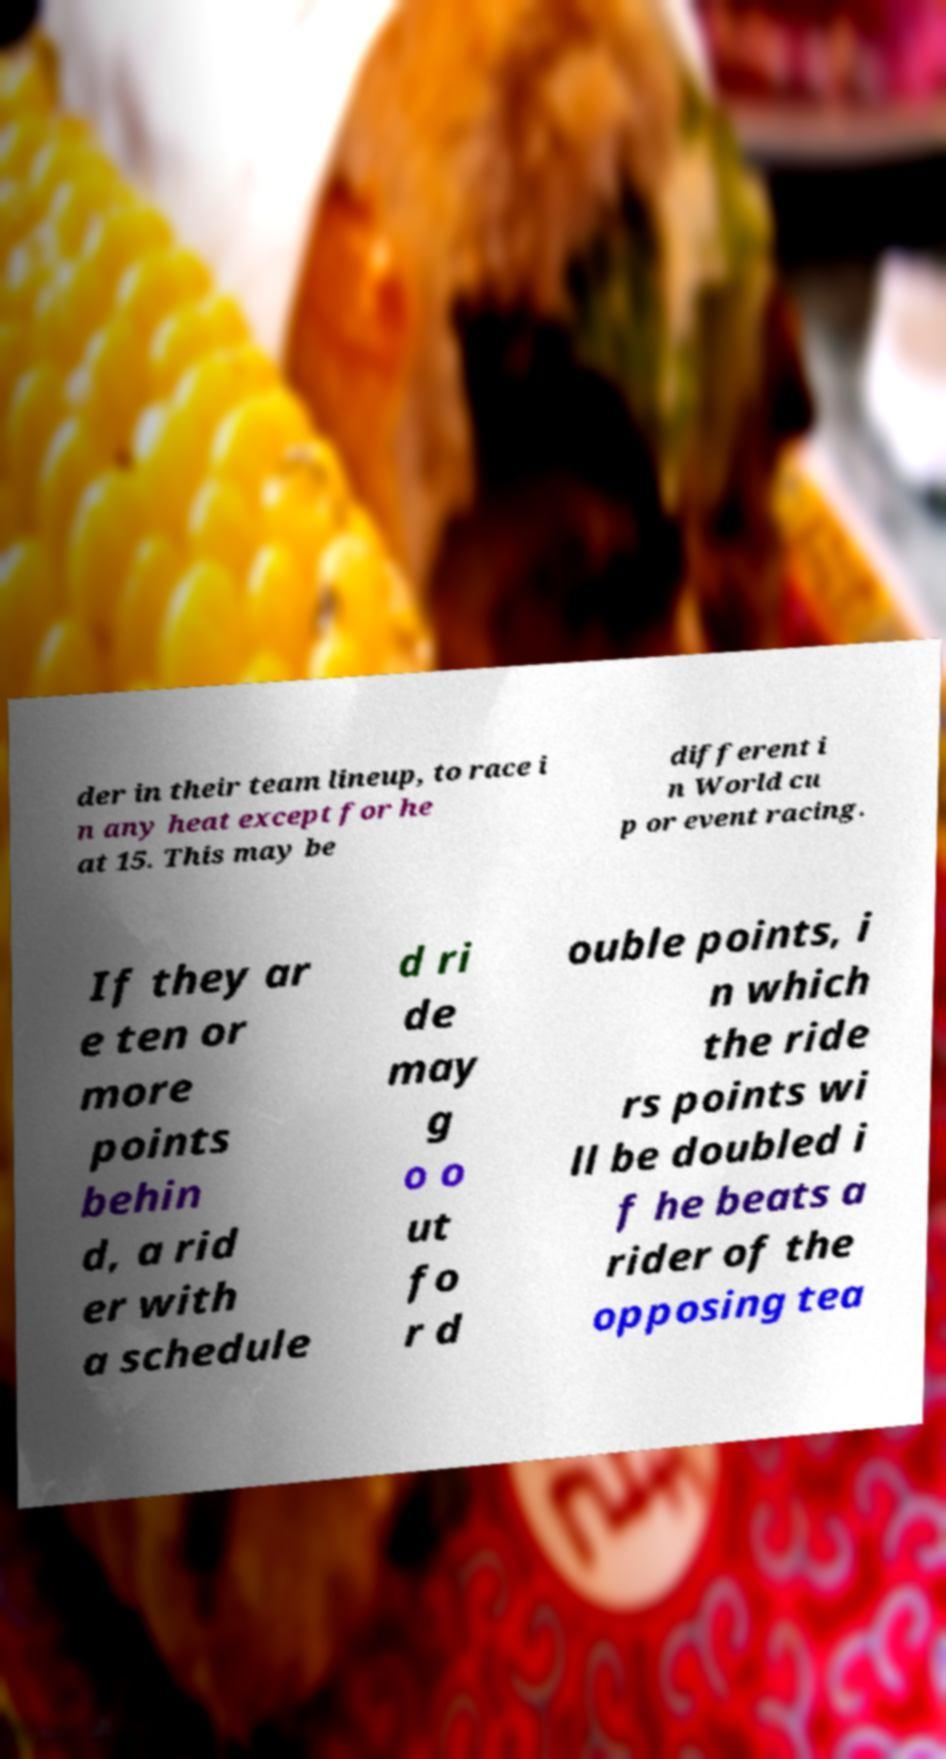There's text embedded in this image that I need extracted. Can you transcribe it verbatim? der in their team lineup, to race i n any heat except for he at 15. This may be different i n World cu p or event racing. If they ar e ten or more points behin d, a rid er with a schedule d ri de may g o o ut fo r d ouble points, i n which the ride rs points wi ll be doubled i f he beats a rider of the opposing tea 